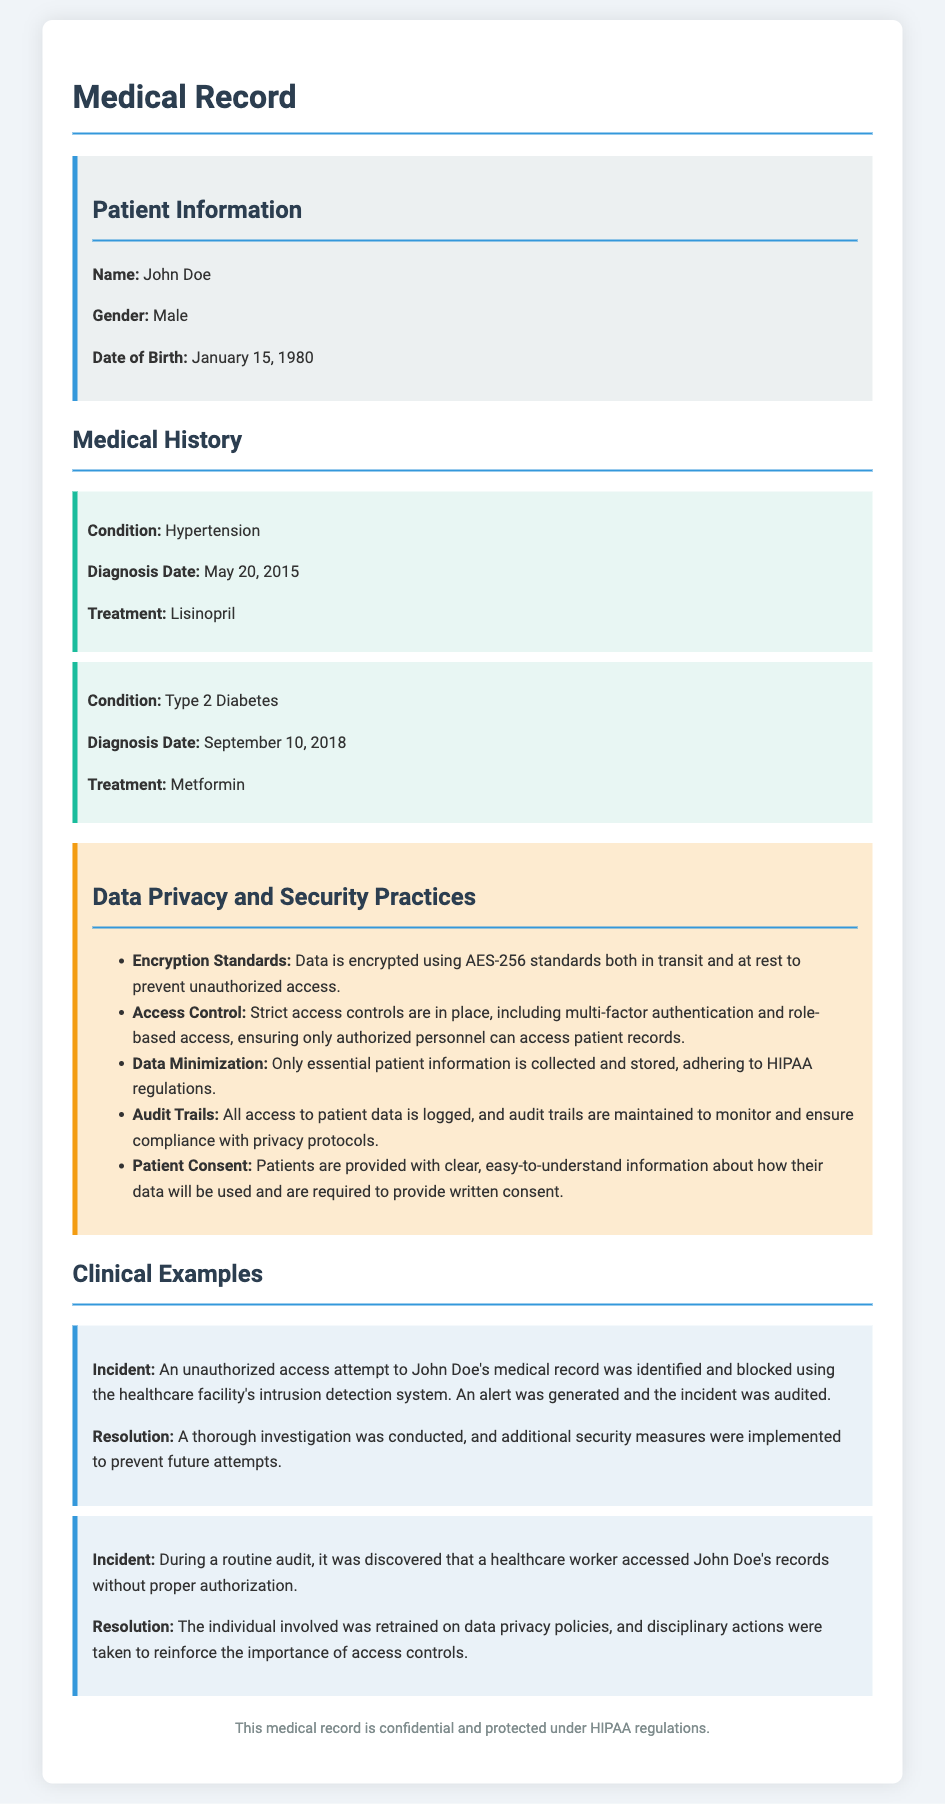What is the patient's name? The patient's name is listed in the patient information section of the document.
Answer: John Doe What condition was diagnosed on May 20, 2015? The specific condition is identified in the medical history section with its corresponding diagnosis date.
Answer: Hypertension What encryption standard is used to protect patient data? The encryption standard is mentioned in the data privacy and security practices.
Answer: AES-256 How is unauthorized access monitored? This information is outlined in the data privacy practices, specifically concerning access to patient data.
Answer: Audit Trails What was the resolution for the unauthorized access incident? The resolution is described in relation to the incident identified in the clinical examples section.
Answer: Additional security measures were implemented What type of authentication is part of access controls? Access control practices include specific methods aimed at securing patient information.
Answer: Multi-factor authentication 